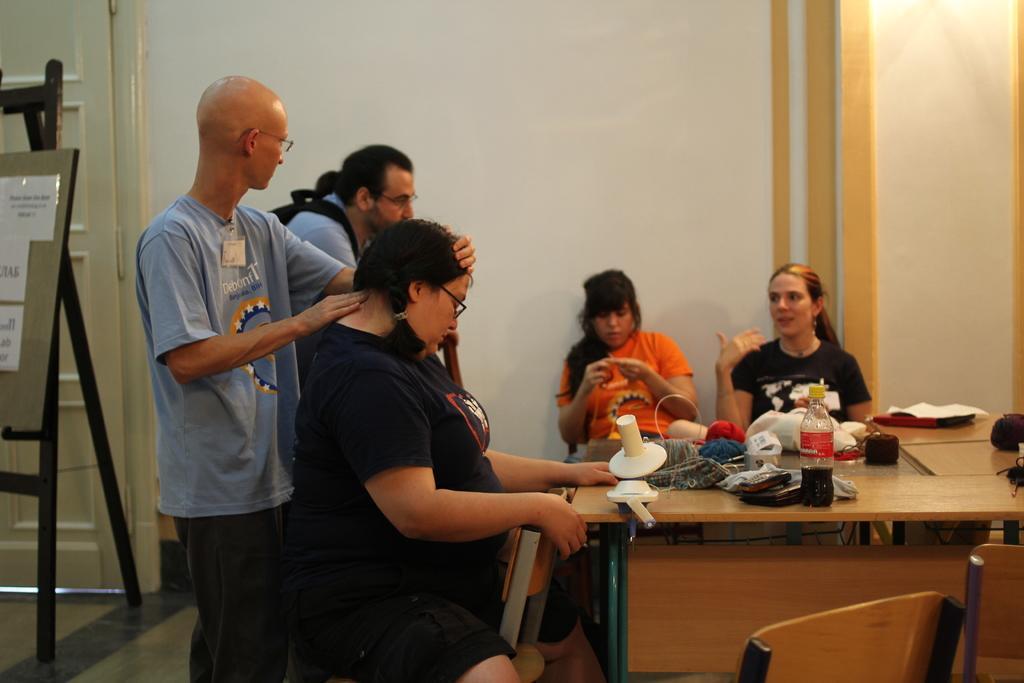Can you describe this image briefly? In this image I can see number of people where two of them are standing and rest all are sitting. On this table I can see a bottle and few more stuffs. I can also see few chairs. 